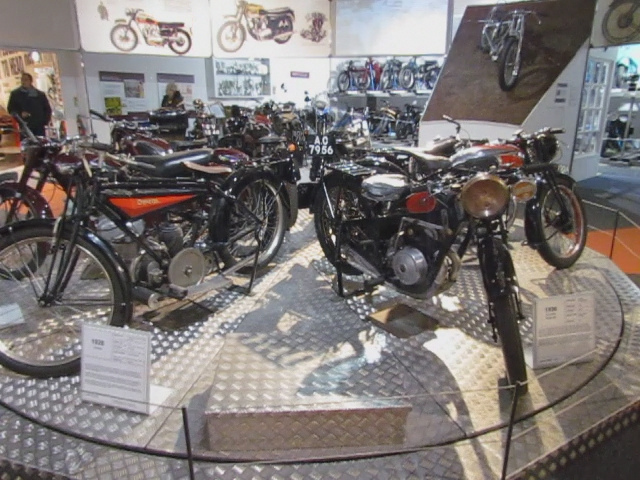What type room is this?
A. living
B. showroom
C. parking garage
D. bathroom
Answer with the option's letter from the given choices directly. B What sort of shop is this?
A. used car
B. motorcycle repair
C. motorcycle sales
D. car sales C 